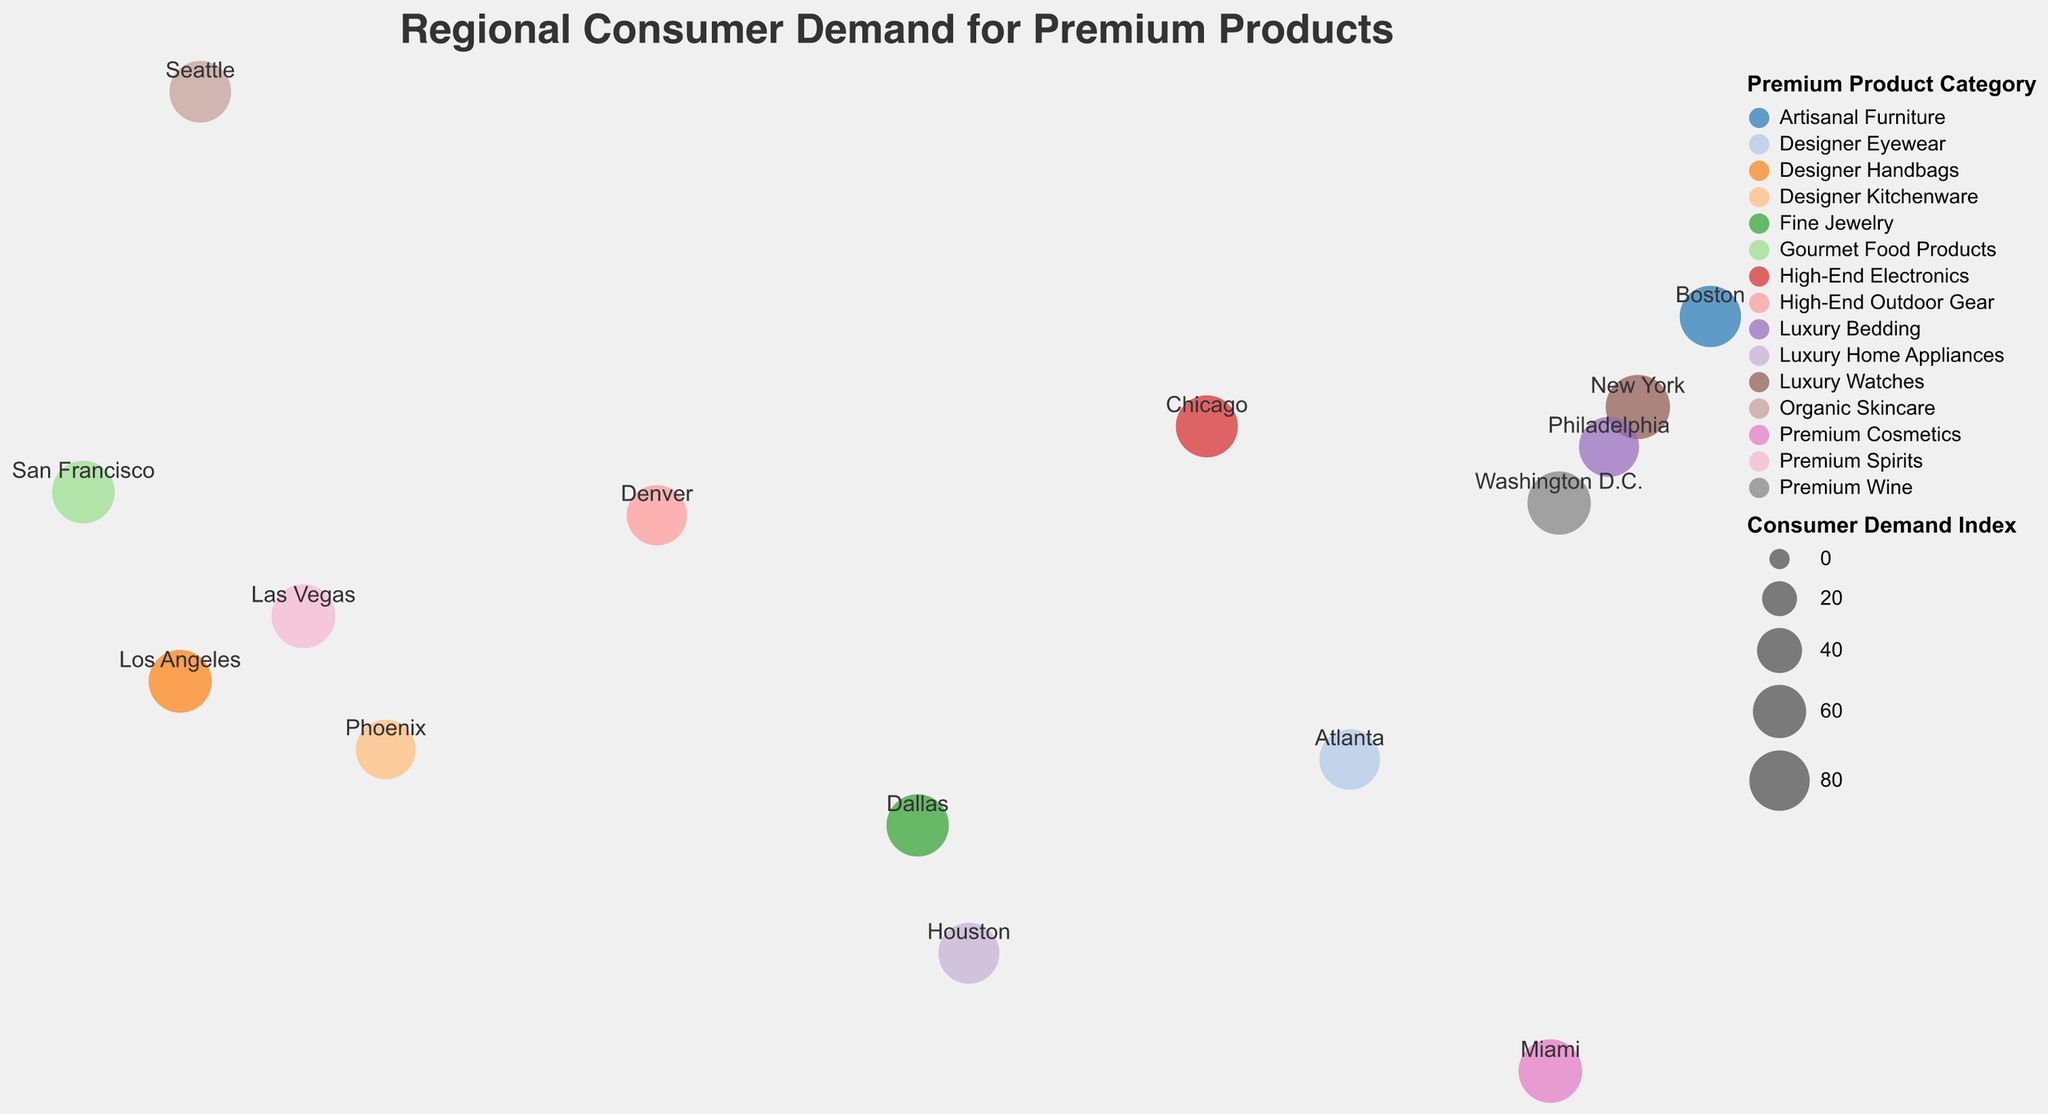What's the title of the figure? The title of the figure is displayed at the top center of the plot. It is written in a reasonably large and bold font, making it easily noticeable.
Answer: Regional Consumer Demand for Premium Products Which region has the highest Consumer Demand Index? To find the region with the highest Consumer Demand Index, observe the size of the circles representing the Consumer Demand Index. The largest circle indicates the highest value. Based on visual inspection, New York has the largest circle.
Answer: New York What premium product is most in demand in Miami? Each region is labeled with its city name, and each circle color corresponds to a premium product. By looking at Miami, the label indicates the premium product is Premium Cosmetics.
Answer: Premium Cosmetics What is the Consumer Demand Index for fine jewelry? Locate the circle colored for Fine Jewelry. The circle representing Fine Jewelry is in Dallas. The size of the circle or any additional tooltip will provide the Consumer Demand Index. In the case of Dallas, the Consumer Demand Index for Fine Jewelry is noted.
Answer: 86 Compare the Consumer Demand Index between Los Angeles and Chicago. Which one is higher? Identify the circles corresponding to Los Angeles and Chicago and compare their sizes or numerical values in the tooltip. Los Angeles has a circle representing 88, while Chicago has a circle representing 85. Thus, Los Angeles has a higher index.
Answer: Los Angeles Compute the average Consumer Demand Index of the West Coast cities (Los Angeles, San Francisco, Seattle). Locate the values for Los Angeles (88), San Francisco (87), and Seattle (84). Sum these values: 88 + 87 + 84 = 259. Divide by the number of cities: 259 / 3 = 86.33.
Answer: 86.33 What is the Consumer Demand Index for Premium Wine, and which city represents it? Look for the circle corresponding to Premium Wine, which is associated with a specific color. The city Washington D.C. is linked to Premium Wine, and its tooltip or label shows the Consumer Demand Index.
Answer: 89 Identify the East Coast city with the lowest Consumer Demand Index and mention its value. Check for the cities on the East Coast and compare their Consumer Demand Index values. Among the cities like New York, Boston, Philadelphia, Miami, and Washington D.C., Philadelphia has the lowest index of 79.
Answer: Philadelphia, 79 Is the Consumer Demand Index for high-end outdoor gear greater than that for designer kitchenware? Locate the circles for Denver (High-End Outdoor Gear) and Phoenix (Designer Kitchenware). Compare their indexes: Denver is 80, and Phoenix is 78, so High-End Outdoor Gear has a higher index.
Answer: Yes 